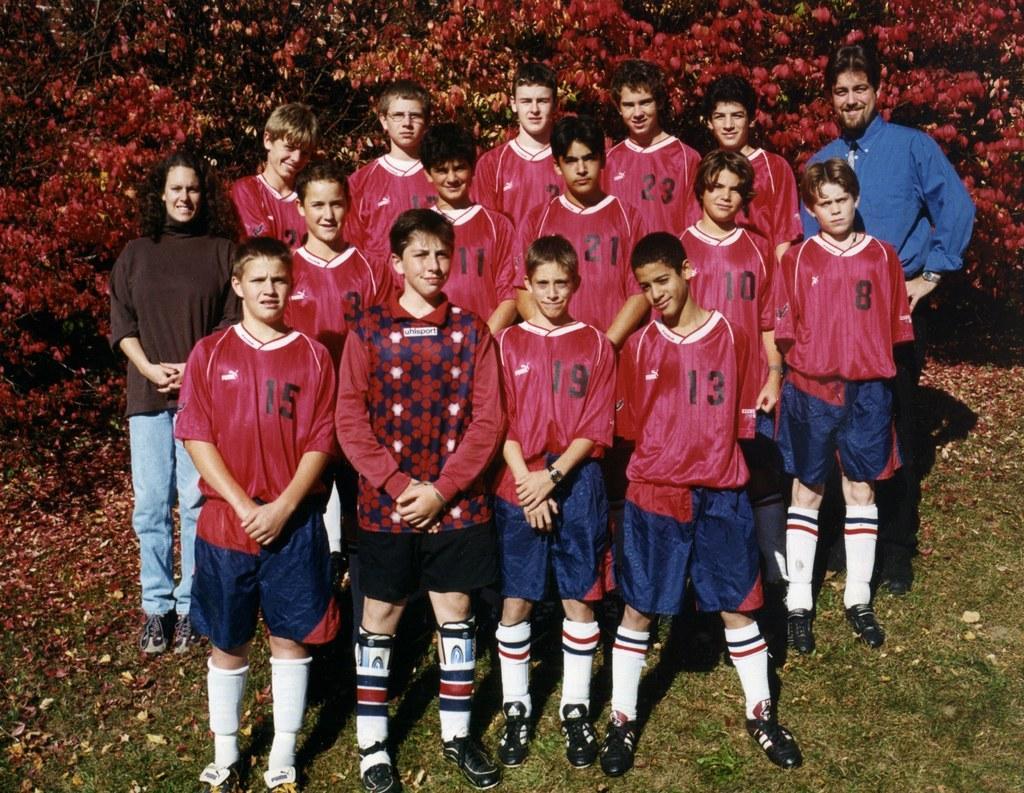How would you summarize this image in a sentence or two? There are few persons standing on the ground. In the background there are trees and leaves on the ground. 